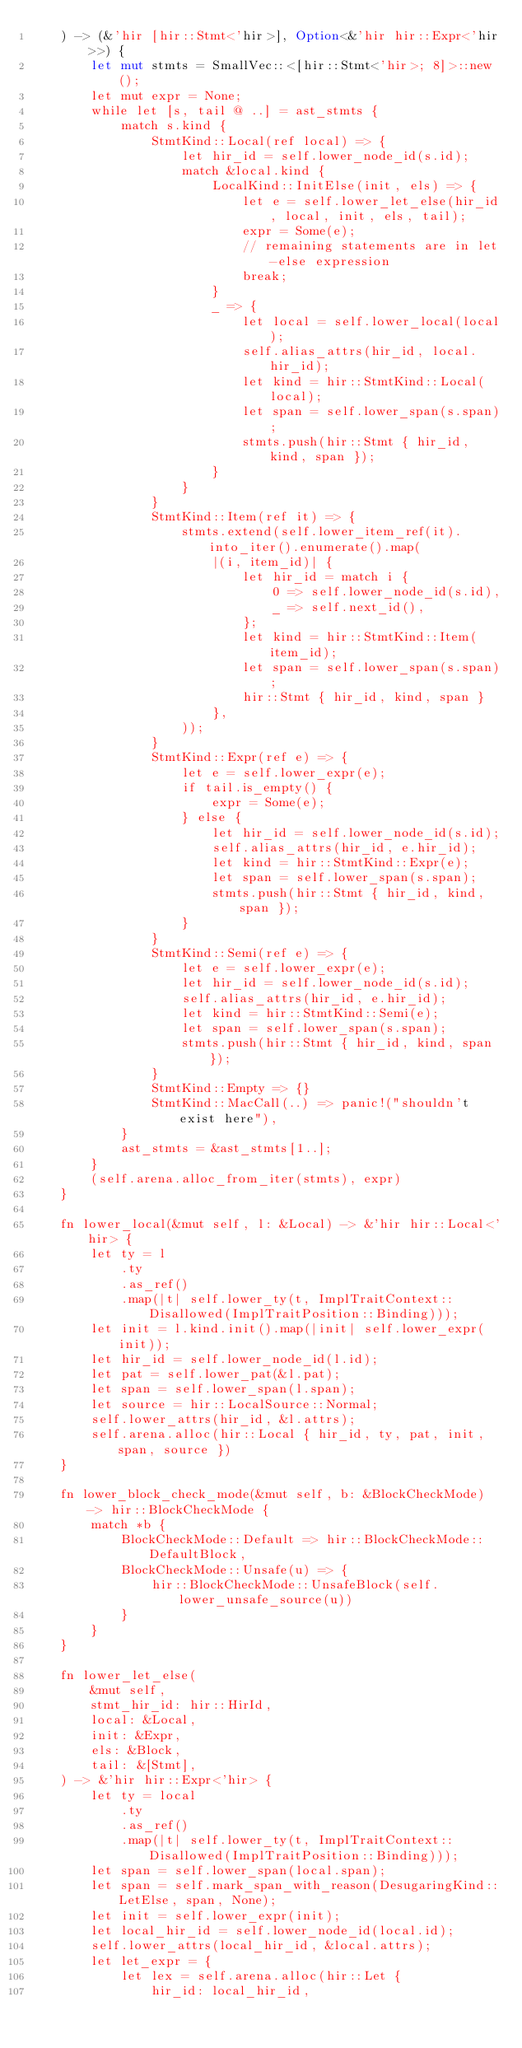Convert code to text. <code><loc_0><loc_0><loc_500><loc_500><_Rust_>    ) -> (&'hir [hir::Stmt<'hir>], Option<&'hir hir::Expr<'hir>>) {
        let mut stmts = SmallVec::<[hir::Stmt<'hir>; 8]>::new();
        let mut expr = None;
        while let [s, tail @ ..] = ast_stmts {
            match s.kind {
                StmtKind::Local(ref local) => {
                    let hir_id = self.lower_node_id(s.id);
                    match &local.kind {
                        LocalKind::InitElse(init, els) => {
                            let e = self.lower_let_else(hir_id, local, init, els, tail);
                            expr = Some(e);
                            // remaining statements are in let-else expression
                            break;
                        }
                        _ => {
                            let local = self.lower_local(local);
                            self.alias_attrs(hir_id, local.hir_id);
                            let kind = hir::StmtKind::Local(local);
                            let span = self.lower_span(s.span);
                            stmts.push(hir::Stmt { hir_id, kind, span });
                        }
                    }
                }
                StmtKind::Item(ref it) => {
                    stmts.extend(self.lower_item_ref(it).into_iter().enumerate().map(
                        |(i, item_id)| {
                            let hir_id = match i {
                                0 => self.lower_node_id(s.id),
                                _ => self.next_id(),
                            };
                            let kind = hir::StmtKind::Item(item_id);
                            let span = self.lower_span(s.span);
                            hir::Stmt { hir_id, kind, span }
                        },
                    ));
                }
                StmtKind::Expr(ref e) => {
                    let e = self.lower_expr(e);
                    if tail.is_empty() {
                        expr = Some(e);
                    } else {
                        let hir_id = self.lower_node_id(s.id);
                        self.alias_attrs(hir_id, e.hir_id);
                        let kind = hir::StmtKind::Expr(e);
                        let span = self.lower_span(s.span);
                        stmts.push(hir::Stmt { hir_id, kind, span });
                    }
                }
                StmtKind::Semi(ref e) => {
                    let e = self.lower_expr(e);
                    let hir_id = self.lower_node_id(s.id);
                    self.alias_attrs(hir_id, e.hir_id);
                    let kind = hir::StmtKind::Semi(e);
                    let span = self.lower_span(s.span);
                    stmts.push(hir::Stmt { hir_id, kind, span });
                }
                StmtKind::Empty => {}
                StmtKind::MacCall(..) => panic!("shouldn't exist here"),
            }
            ast_stmts = &ast_stmts[1..];
        }
        (self.arena.alloc_from_iter(stmts), expr)
    }

    fn lower_local(&mut self, l: &Local) -> &'hir hir::Local<'hir> {
        let ty = l
            .ty
            .as_ref()
            .map(|t| self.lower_ty(t, ImplTraitContext::Disallowed(ImplTraitPosition::Binding)));
        let init = l.kind.init().map(|init| self.lower_expr(init));
        let hir_id = self.lower_node_id(l.id);
        let pat = self.lower_pat(&l.pat);
        let span = self.lower_span(l.span);
        let source = hir::LocalSource::Normal;
        self.lower_attrs(hir_id, &l.attrs);
        self.arena.alloc(hir::Local { hir_id, ty, pat, init, span, source })
    }

    fn lower_block_check_mode(&mut self, b: &BlockCheckMode) -> hir::BlockCheckMode {
        match *b {
            BlockCheckMode::Default => hir::BlockCheckMode::DefaultBlock,
            BlockCheckMode::Unsafe(u) => {
                hir::BlockCheckMode::UnsafeBlock(self.lower_unsafe_source(u))
            }
        }
    }

    fn lower_let_else(
        &mut self,
        stmt_hir_id: hir::HirId,
        local: &Local,
        init: &Expr,
        els: &Block,
        tail: &[Stmt],
    ) -> &'hir hir::Expr<'hir> {
        let ty = local
            .ty
            .as_ref()
            .map(|t| self.lower_ty(t, ImplTraitContext::Disallowed(ImplTraitPosition::Binding)));
        let span = self.lower_span(local.span);
        let span = self.mark_span_with_reason(DesugaringKind::LetElse, span, None);
        let init = self.lower_expr(init);
        let local_hir_id = self.lower_node_id(local.id);
        self.lower_attrs(local_hir_id, &local.attrs);
        let let_expr = {
            let lex = self.arena.alloc(hir::Let {
                hir_id: local_hir_id,</code> 